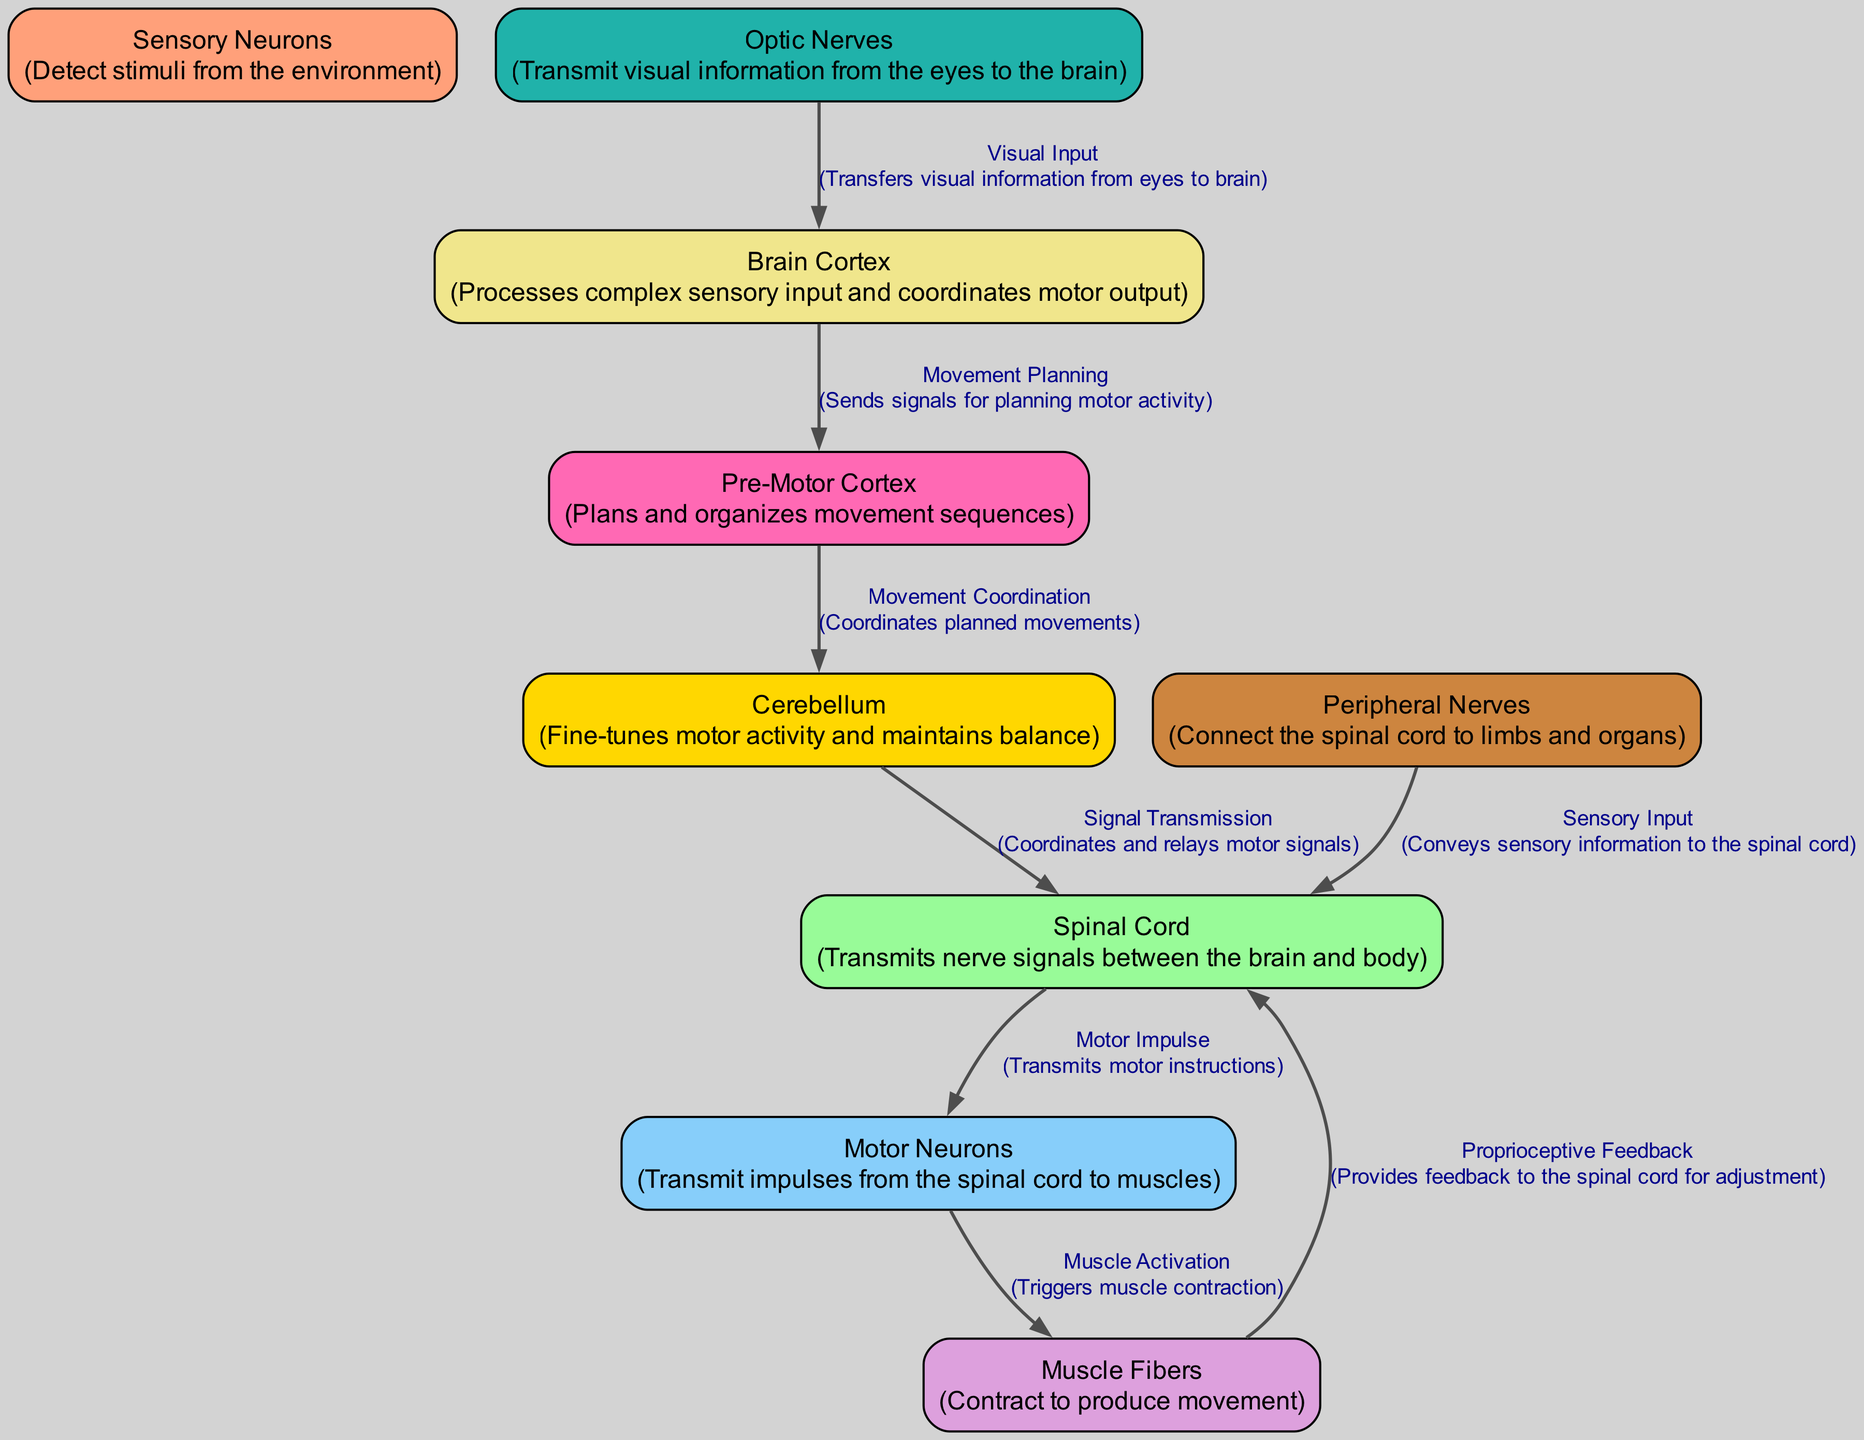What's the first node in the reflex pathway? The diagram starts with the "Optic Nerves," which detect visual stimuli and transmit this information.
Answer: Optic Nerves How many nodes are present in this diagram? The diagram includes a total of 9 nodes, each representing a component in the motor reflex pathway.
Answer: 9 What does the "Brain Cortex" primarily do? The "Brain Cortex" processes complex sensory input and coordinates motor output, acting as a central hub for information.
Answer: Processes complex sensory input and coordinates motor output Which node receives sensory input from the optic nerves? The "Brain Cortex" receives visual information from the "Optic Nerves," allowing for the processing of what is seen.
Answer: Brain Cortex What is the role of "Motor Neurons" in the reflex pathway? "Motor Neurons" transmit impulses from the spinal cord to the muscle fibers, facilitating movement.
Answer: Transmit impulses from the spinal cord to muscles Which two nodes form the connection for proprioceptive feedback? The "Muscle Fibers" provide feedback back to the "Spinal Cord," which allows for coordination and adjustment of movement.
Answer: Muscle Fibers and Spinal Cord What signal is transmitted from the "Cerebellum" to the "Spinal Cord"? The "Cerebellum" sends coordinated and adjusted motor signals from its processing functions, enabling smooth motion.
Answer: Signal Transmission What type of input do "Peripheral Nerves" convey? "Peripheral Nerves" convey sensory input to the spinal cord, connecting the limb sensations back to the central nervous system.
Answer: Sensory Input Which component fine-tunes motor activity? The "Cerebellum" is responsible for fine-tuning motor activity and maintaining balance during movement.
Answer: Cerebellum 